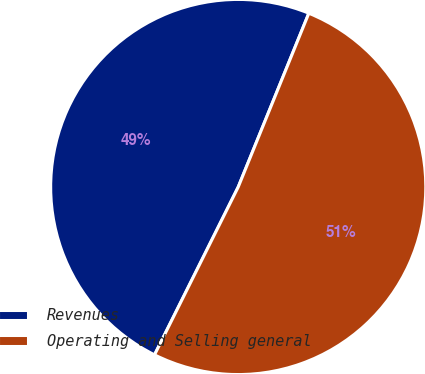<chart> <loc_0><loc_0><loc_500><loc_500><pie_chart><fcel>Revenues<fcel>Operating and Selling general<nl><fcel>48.78%<fcel>51.22%<nl></chart> 